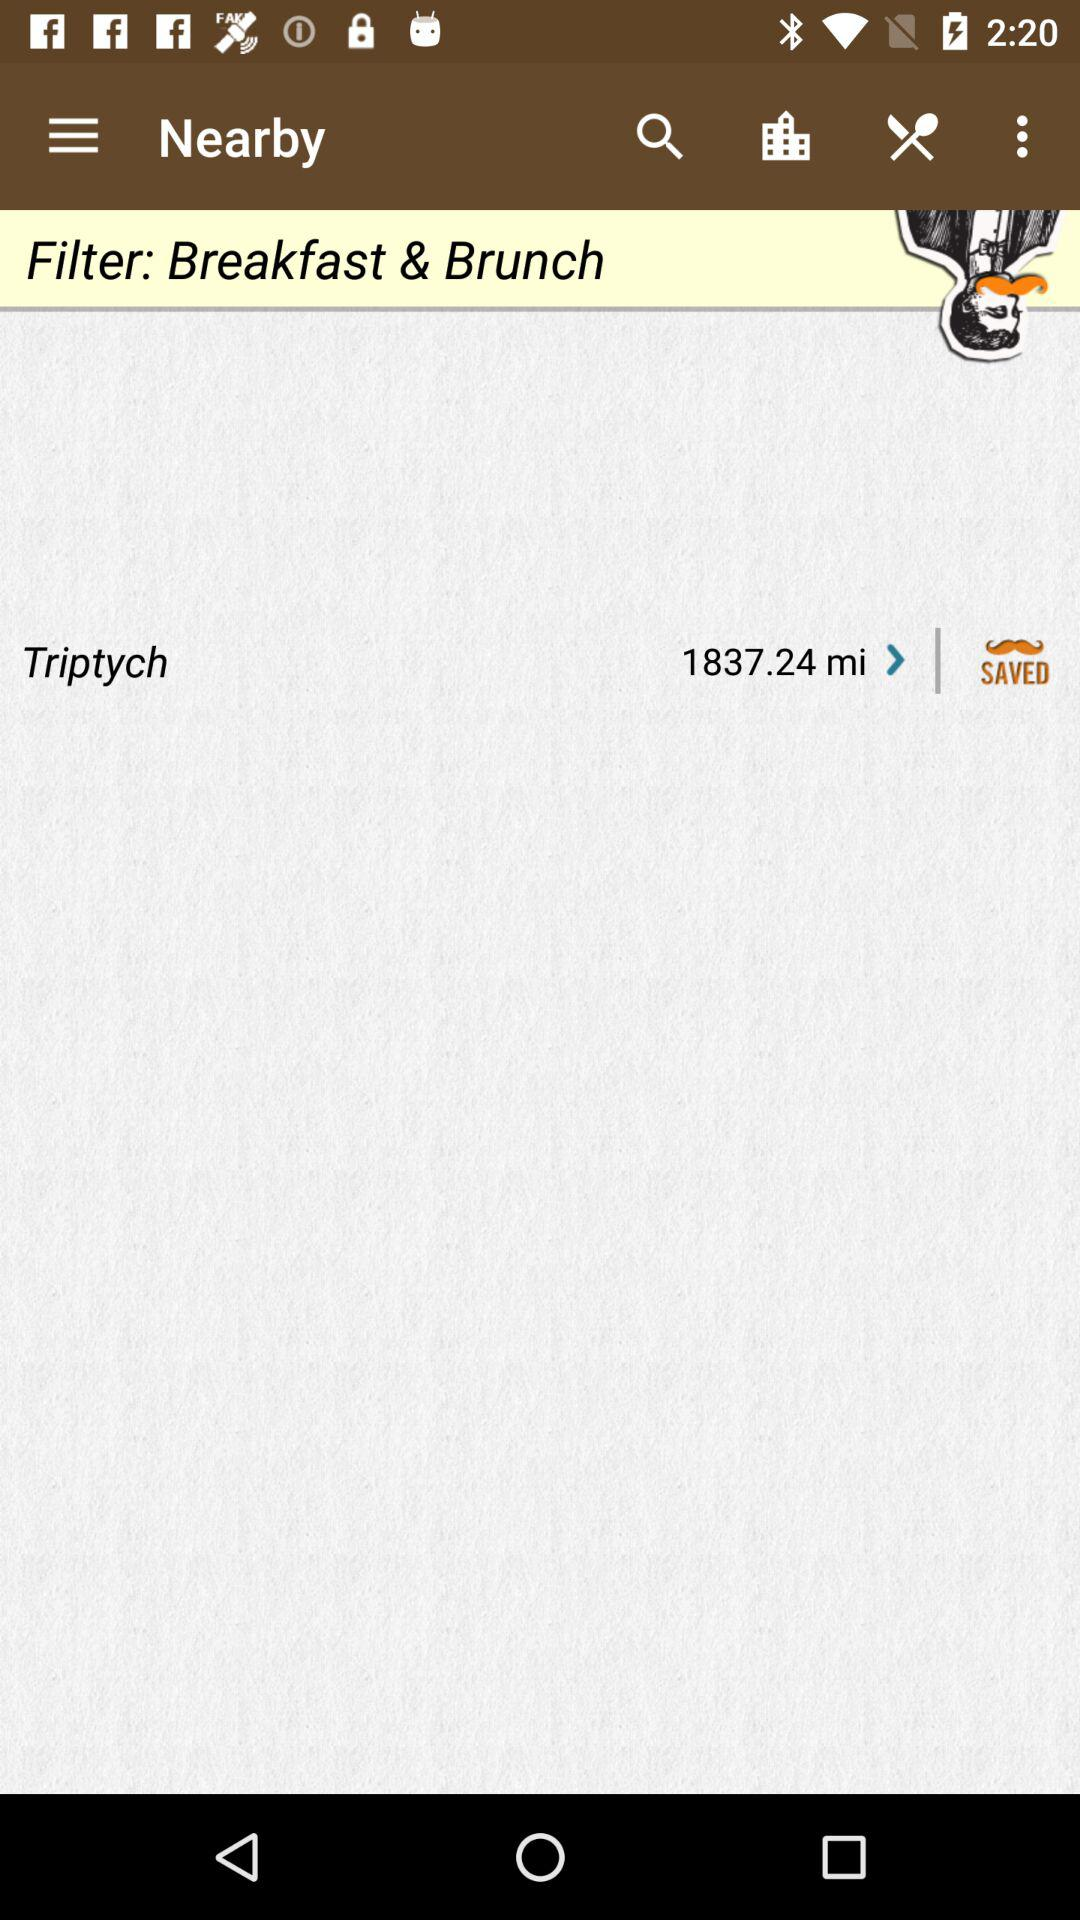What is the difference in distance between the restaurant and the user's location?
Answer the question using a single word or phrase. 1837.24 mi 